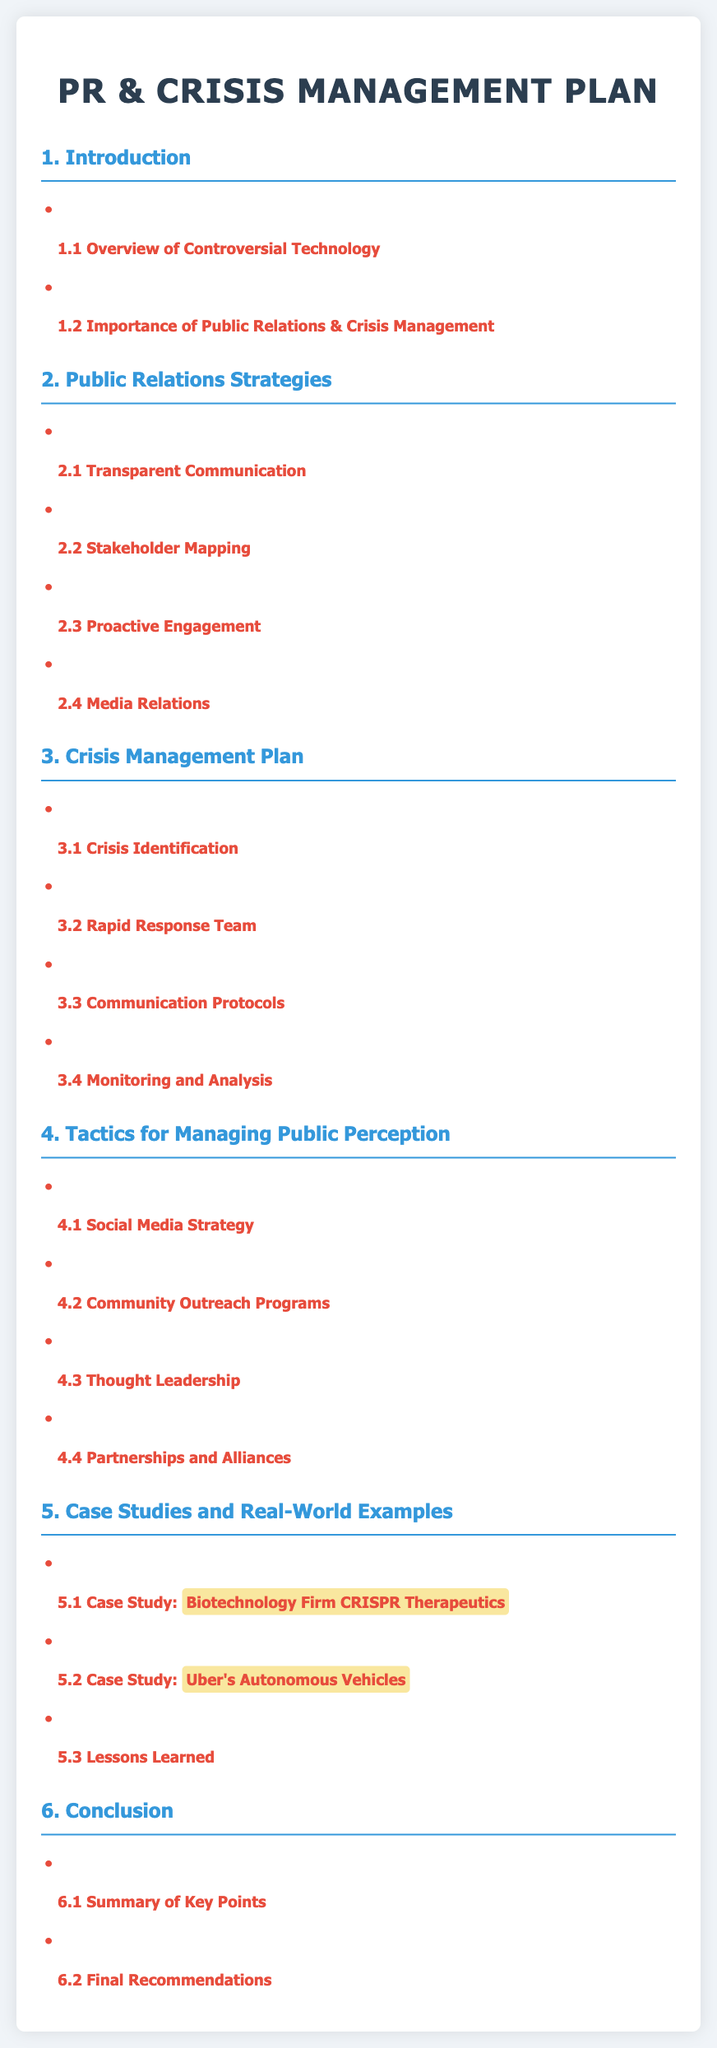What is the title of the document? The title of the document is specified in the HTML head section.
Answer: PR & Crisis Management for Controversial Tech What is the first section about? The first section discusses two main topics as indicated by the subheadings.
Answer: Overview of Controversial Technology How many public relations strategies are listed? The document provides a total count of strategies under the Public Relations Strategies section.
Answer: 4 What is a recommended tactic for managing public perception? The document lists several tactics under the section for public perception management.
Answer: Social Media Strategy Which case study highlights a biotechnology firm? The document mentions specific examples of organizations in the Case Studies section.
Answer: CRISPR Therapeutics What is one key element of the Crisis Management Plan? There are specific components under the Crisis Management Plan in the document.
Answer: Crisis Identification How many case studies are provided in the document? The document outlines the number of case studies under the Case Studies and Real-World Examples section.
Answer: 3 What is the color of the section titles? The section titles have a specific color assigned in the document's CSS.
Answer: #3498db What is included in the conclusion section? The conclusion section summarizes key points and offers final insights as stated in the document.
Answer: Summary of Key Points 